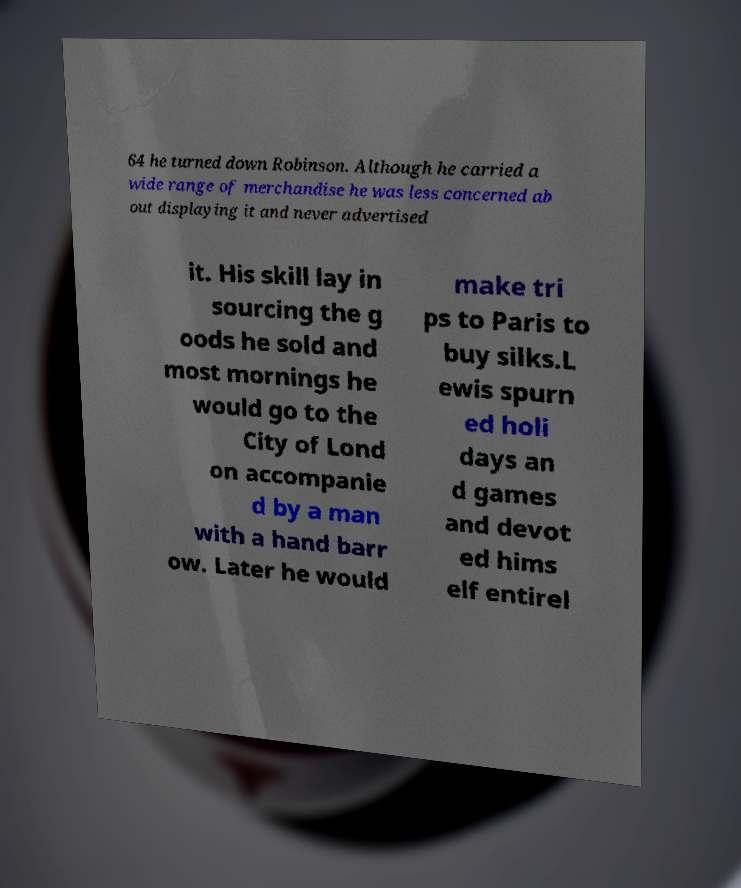There's text embedded in this image that I need extracted. Can you transcribe it verbatim? 64 he turned down Robinson. Although he carried a wide range of merchandise he was less concerned ab out displaying it and never advertised it. His skill lay in sourcing the g oods he sold and most mornings he would go to the City of Lond on accompanie d by a man with a hand barr ow. Later he would make tri ps to Paris to buy silks.L ewis spurn ed holi days an d games and devot ed hims elf entirel 